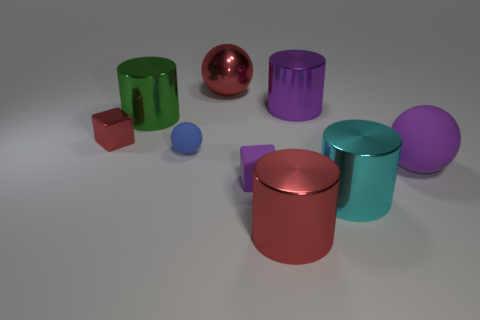There is a rubber object that is the same color as the large matte ball; what shape is it?
Provide a short and direct response. Cube. Are there any big purple things in front of the purple thing that is on the left side of the red thing that is on the right side of the purple matte cube?
Give a very brief answer. No. Are there more large objects that are in front of the large green object than brown metallic blocks?
Ensure brevity in your answer.  Yes. Do the large object left of the blue ball and the large cyan object have the same shape?
Your answer should be very brief. Yes. What number of objects are either small gray blocks or large shiny objects that are left of the large cyan metallic cylinder?
Provide a succinct answer. 4. There is a shiny cylinder that is both in front of the green cylinder and left of the big cyan cylinder; what size is it?
Offer a very short reply. Large. Are there more shiny cylinders that are behind the tiny blue ball than blocks right of the large green cylinder?
Provide a succinct answer. Yes. Is the shape of the small red metallic thing the same as the purple rubber object that is on the left side of the cyan object?
Your answer should be very brief. Yes. What number of other objects are the same shape as the green metallic object?
Keep it short and to the point. 3. What is the color of the big cylinder that is on the right side of the red cylinder and behind the metal block?
Your answer should be compact. Purple. 